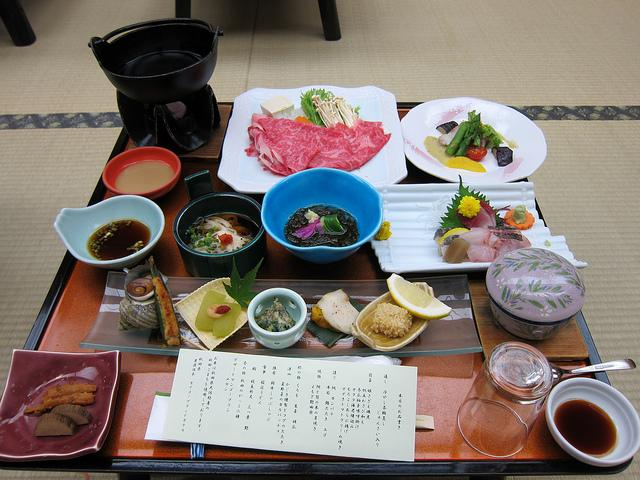Which food will add an acidic flavor to the food? lemon 